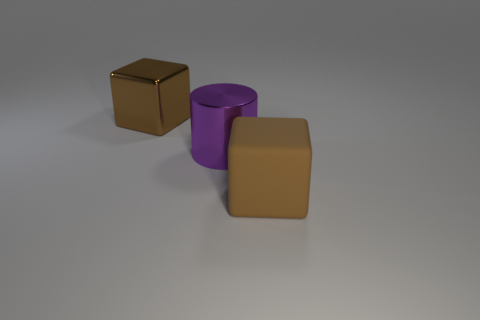Is the color of the large rubber object the same as the metal block?
Give a very brief answer. Yes. Do the brown thing that is left of the purple thing and the large brown object in front of the large purple thing have the same shape?
Offer a very short reply. Yes. What color is the shiny cylinder that is to the left of the brown matte thing?
Provide a short and direct response. Purple. Are there any large brown shiny objects of the same shape as the large matte object?
Provide a short and direct response. Yes. There is another big cube that is the same color as the shiny cube; what is it made of?
Offer a very short reply. Rubber. How many small blue matte cylinders are there?
Offer a terse response. 0. Is the number of big purple cylinders less than the number of large metal objects?
Your answer should be compact. Yes. There is a purple object that is the same size as the brown metallic object; what is it made of?
Offer a terse response. Metal. How many objects are large brown cubes or purple objects?
Your answer should be very brief. 3. How many brown cubes are right of the big metal cylinder and left of the metallic cylinder?
Provide a short and direct response. 0. 